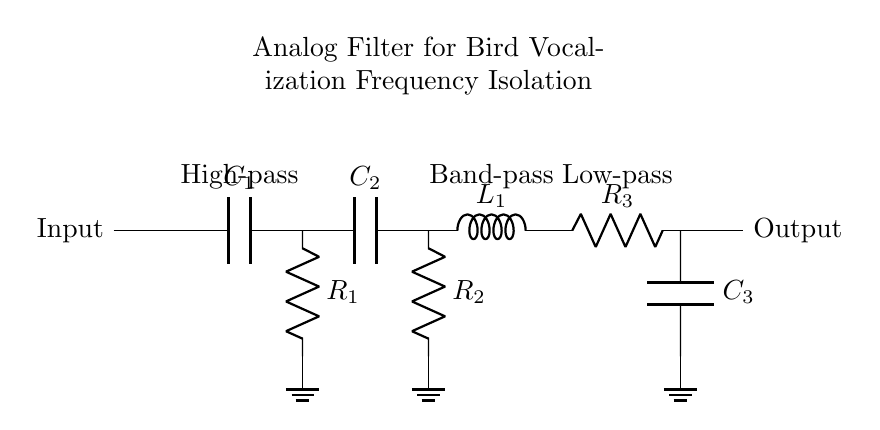What type of filter is first in the circuit? The circuit starts with a high-pass filter, indicated by the capacitor connected in series with a resistor. This configuration allows frequencies above a certain cutoff to pass while attenuating lower frequencies.
Answer: High-pass What components comprise the band-pass filter section? The band-pass filter section is made up of a capacitor, resistor, and an inductor, which together allow a specific frequency range to pass while blocking frequencies outside this range.
Answer: Capacitor, resistor, and inductor How many resistors are present in the entire circuit? There are three resistors shown in the diagram, as indicated by the symbol "R" with numbers 1, 2, and 3 next to them.
Answer: Three What does the output of the circuit represent? The output of the circuit represents the filtered signal after various frequency ranges have been isolated, specifically intended to capture the relevant bird vocalization frequencies by removing unwanted noise or frequencies.
Answer: Filtered signal What is the purpose of the low-pass filter in this circuit? The low-pass filter allows frequencies below a certain threshold to be passed while blocking higher frequencies, making it useful for cleaning up high-frequency noise that could interfere with the recorded bird vocalizations.
Answer: Attenuate high frequencies 